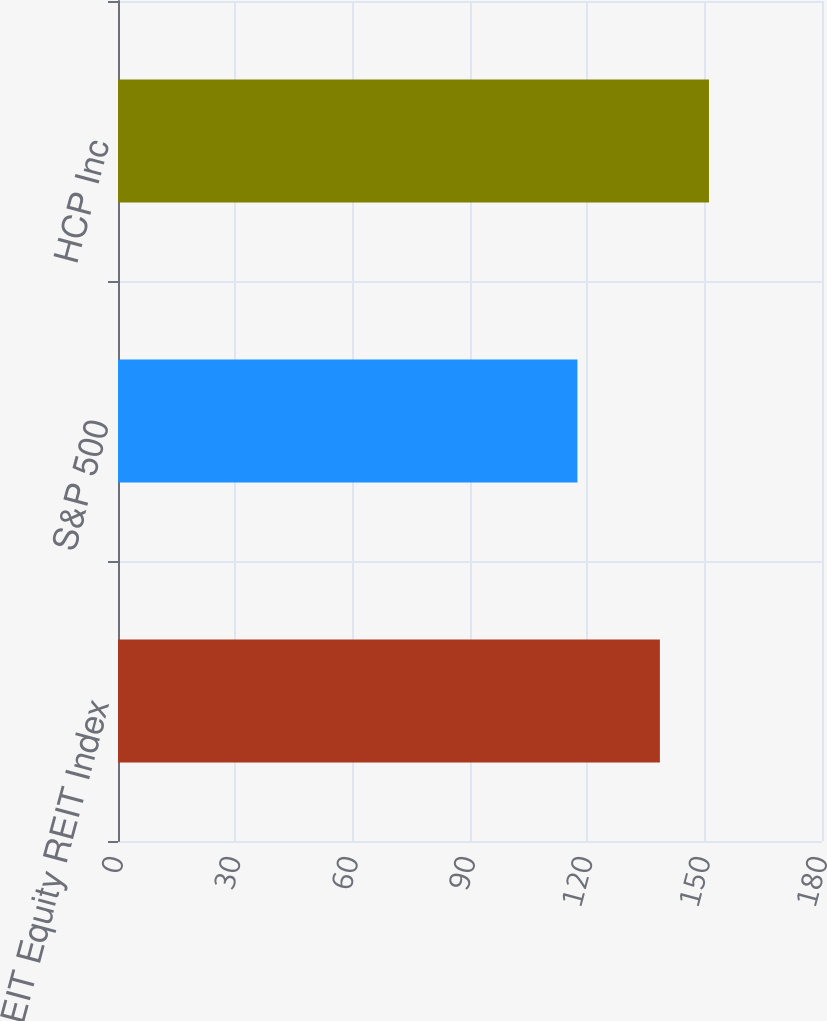<chart> <loc_0><loc_0><loc_500><loc_500><bar_chart><fcel>FTSE NAREIT Equity REIT Index<fcel>S&P 500<fcel>HCP Inc<nl><fcel>138.55<fcel>117.47<fcel>151.1<nl></chart> 